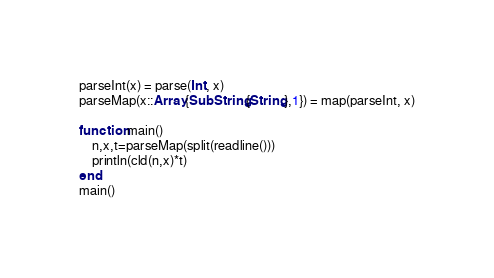Convert code to text. <code><loc_0><loc_0><loc_500><loc_500><_Julia_>parseInt(x) = parse(Int, x)
parseMap(x::Array{SubString{String},1}) = map(parseInt, x)

function main()
    n,x,t=parseMap(split(readline()))
    println(cld(n,x)*t)
end
main()</code> 